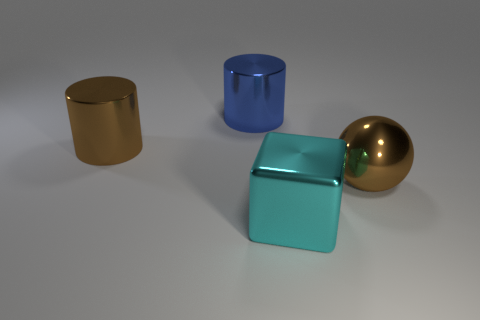Subtract all blocks. How many objects are left? 3 Add 3 large cyan rubber spheres. How many objects exist? 7 Subtract 0 red balls. How many objects are left? 4 Subtract all big metallic blocks. Subtract all small brown matte spheres. How many objects are left? 3 Add 1 large metallic cubes. How many large metallic cubes are left? 2 Add 1 tiny gray rubber cubes. How many tiny gray rubber cubes exist? 1 